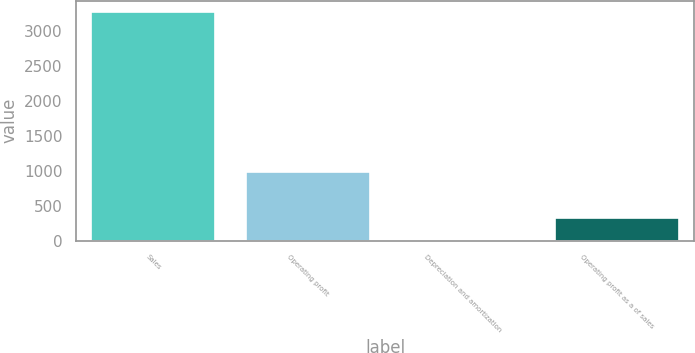Convert chart to OTSL. <chart><loc_0><loc_0><loc_500><loc_500><bar_chart><fcel>Sales<fcel>Operating profit<fcel>Depreciation and amortization<fcel>Operating profit as a of sales<nl><fcel>3265.5<fcel>981.05<fcel>2<fcel>328.35<nl></chart> 